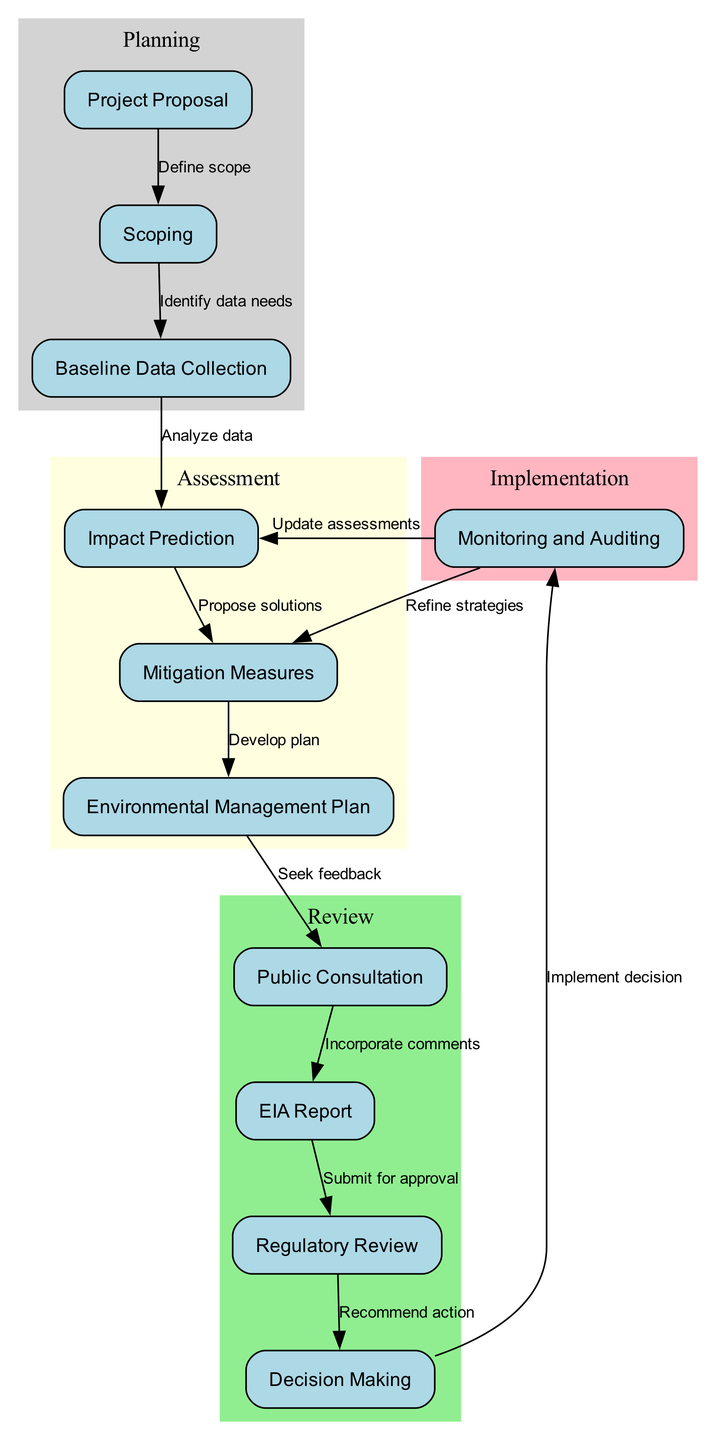What is the first step in the environmental impact assessment workflow? The first step is indicated by the starting node in the diagram, which is "Project Proposal."
Answer: Project Proposal How many nodes are there in the diagram? The diagram contains a total of eleven nodes, as listed in the data provided.
Answer: Eleven What follows after "Impact Prediction"? The diagram shows that after "Impact Prediction," the next step is "Mitigation Measures."
Answer: Mitigation Measures Which node incorporates comments from public consultation? The diagram indicates that "EIA Report" incorporates comments derived from the "Public Consultation" step.
Answer: EIA Report How many feedback loops are present in the workflow? The diagram includes two feedback loops: one returning from "Monitoring and Auditing" to "Impact Prediction" and another from "Monitoring and Auditing" to "Mitigation Measures."
Answer: Two What action is taken after the "Regulatory Review" node? According to the diagram, the action following "Regulatory Review" is "Decision Making."
Answer: Decision Making Which two nodes are categorized under the "Implementation" phase? The "Implementation" phase is represented by the node "Monitoring and Auditing" only; thus, it is the only one categorized under that phase.
Answer: Monitoring and Auditing What is the relationship between "Mitigation Measures" and "EIA Report"? The diagram shows that "Mitigation Measures" leads to the development of the "Environmental Management Plan," which eventually feeds into the "EIA Report."
Answer: Indirect relationship Which node is directly connected to "Monitoring and Auditing"? The "Monitoring and Auditing" node connects directly to two nodes: "Impact Prediction" and "Mitigation Measures."
Answer: Impact Prediction and Mitigation Measures 